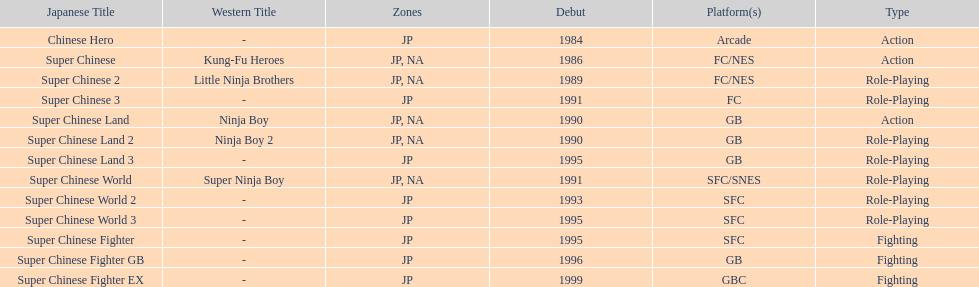What are the total of super chinese games released? 13. 